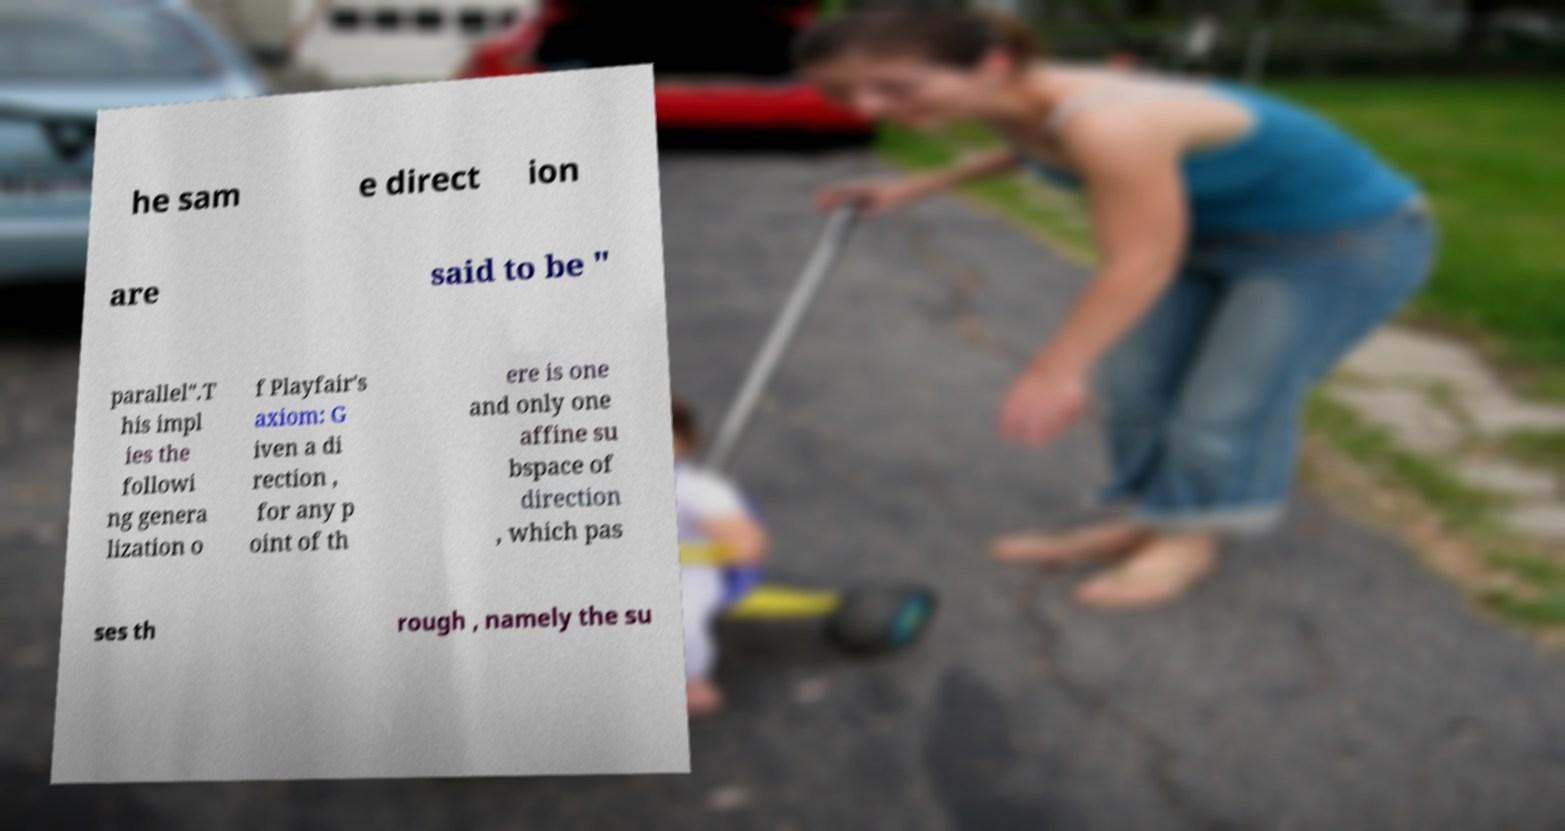Could you extract and type out the text from this image? he sam e direct ion are said to be " parallel".T his impl ies the followi ng genera lization o f Playfair's axiom: G iven a di rection , for any p oint of th ere is one and only one affine su bspace of direction , which pas ses th rough , namely the su 